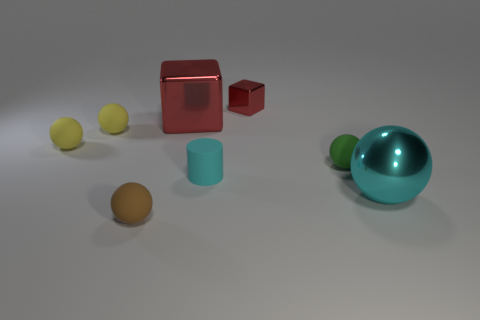Subtract all green spheres. How many spheres are left? 4 Subtract all small brown spheres. How many spheres are left? 4 Subtract 0 blue spheres. How many objects are left? 8 Subtract all cylinders. How many objects are left? 7 Subtract 1 cubes. How many cubes are left? 1 Subtract all brown blocks. Subtract all brown spheres. How many blocks are left? 2 Subtract all yellow balls. How many purple cubes are left? 0 Subtract all tiny green matte things. Subtract all matte balls. How many objects are left? 3 Add 1 yellow objects. How many yellow objects are left? 3 Add 6 gray metallic balls. How many gray metallic balls exist? 6 